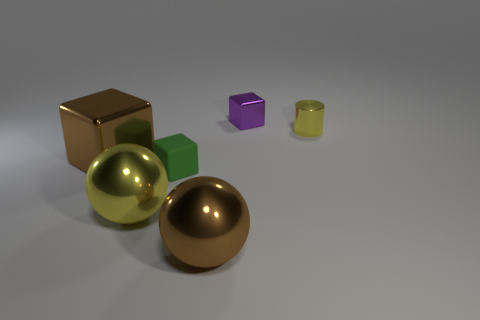What number of other objects are there of the same color as the small metallic cylinder?
Keep it short and to the point. 1. There is a metallic cylinder; is its size the same as the yellow shiny thing on the left side of the tiny purple metal object?
Keep it short and to the point. No. There is a purple cube that is behind the tiny block on the left side of the purple metallic thing; what size is it?
Ensure brevity in your answer.  Small. There is a large object that is the same shape as the tiny purple thing; what is its color?
Provide a short and direct response. Brown. Is the brown sphere the same size as the green object?
Make the answer very short. No. Are there the same number of tiny matte things that are in front of the big yellow object and big cyan spheres?
Provide a short and direct response. Yes. There is a metal cube in front of the yellow metallic cylinder; is there a large yellow ball left of it?
Provide a succinct answer. No. There is a yellow cylinder right of the shiny ball to the left of the tiny object on the left side of the tiny purple block; what is its size?
Offer a very short reply. Small. There is a brown object right of the shiny block in front of the small cylinder; what is its material?
Offer a terse response. Metal. Are there any other tiny objects of the same shape as the tiny green thing?
Provide a short and direct response. Yes. 